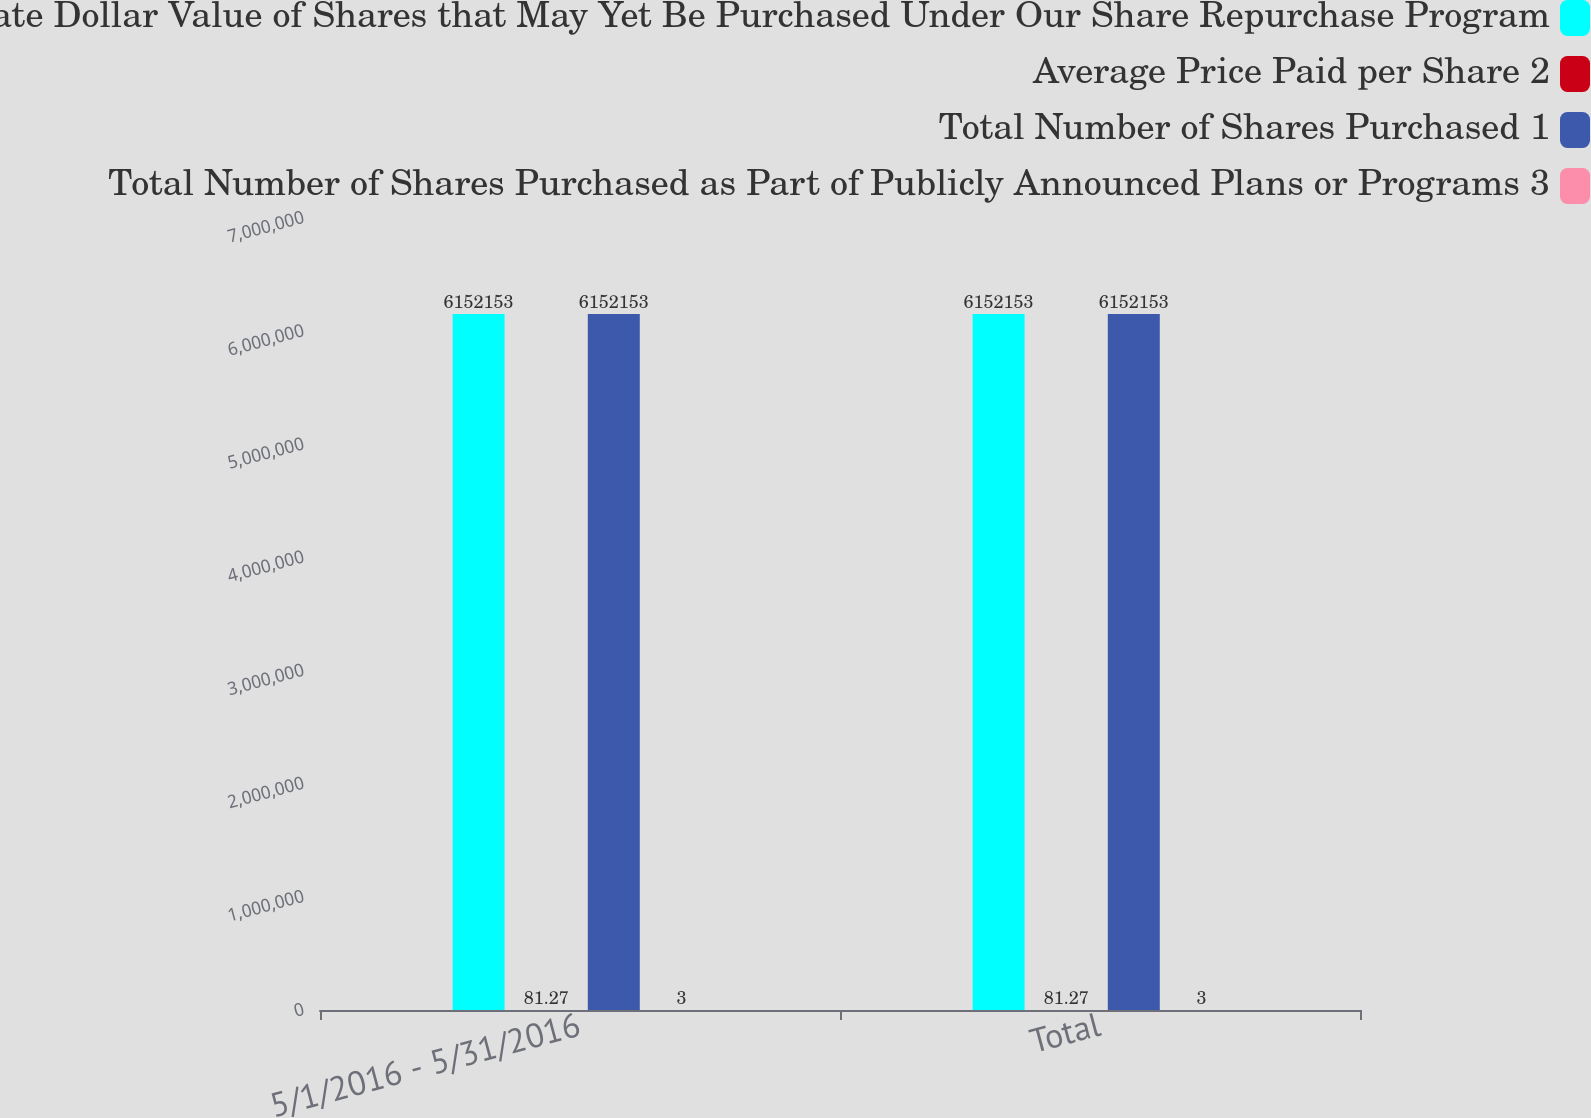<chart> <loc_0><loc_0><loc_500><loc_500><stacked_bar_chart><ecel><fcel>5/1/2016 - 5/31/2016<fcel>Total<nl><fcel>Approximate Dollar Value of Shares that May Yet Be Purchased Under Our Share Repurchase Program<fcel>6.15215e+06<fcel>6.15215e+06<nl><fcel>Average Price Paid per Share 2<fcel>81.27<fcel>81.27<nl><fcel>Total Number of Shares Purchased 1<fcel>6.15215e+06<fcel>6.15215e+06<nl><fcel>Total Number of Shares Purchased as Part of Publicly Announced Plans or Programs 3<fcel>3<fcel>3<nl></chart> 